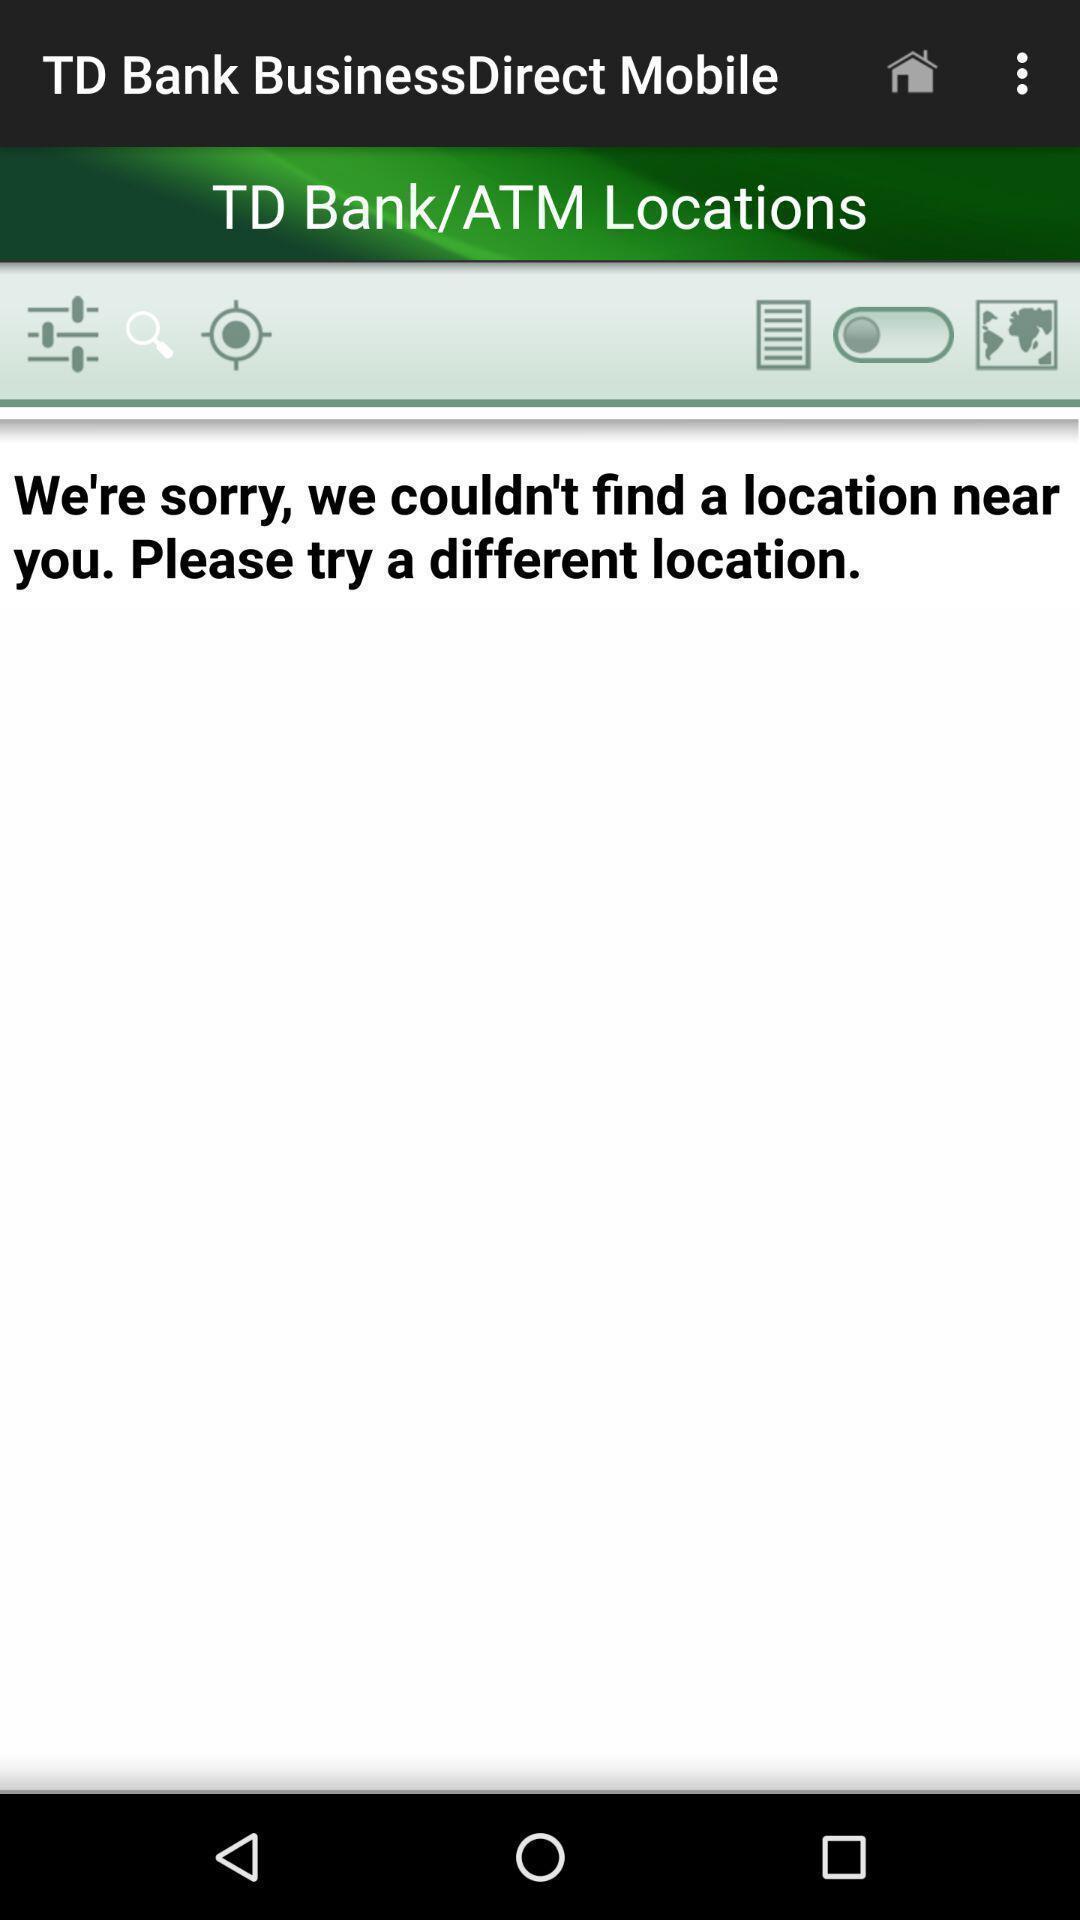Summarize the main components in this picture. Page for atm locator in banking application. 